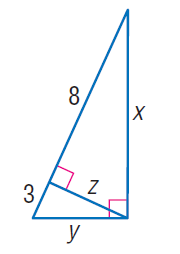Answer the mathemtical geometry problem and directly provide the correct option letter.
Question: Find y.
Choices: A: 2 \sqrt { 6 } B: \sqrt { 33 } C: \sqrt { 34 } D: 2 \sqrt { 11 } B 